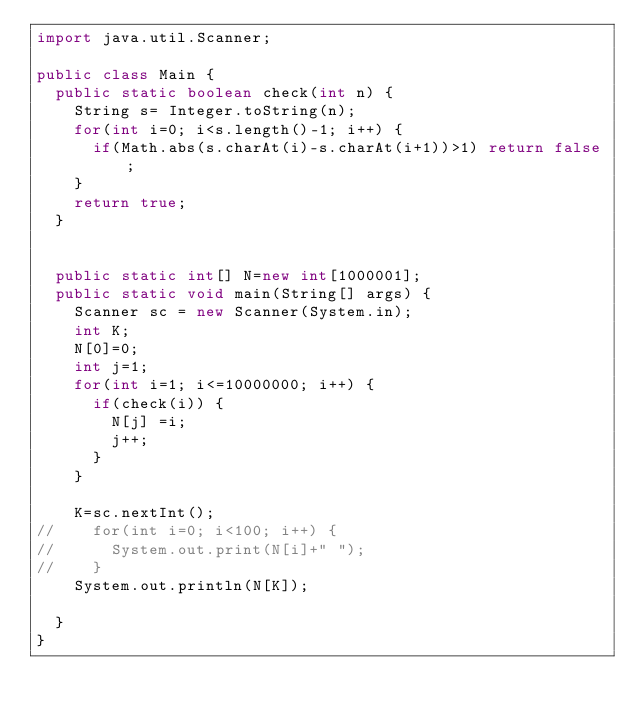<code> <loc_0><loc_0><loc_500><loc_500><_Java_>import java.util.Scanner;

public class Main {
	public static boolean check(int n) {
		String s= Integer.toString(n);
		for(int i=0; i<s.length()-1; i++) {
			if(Math.abs(s.charAt(i)-s.charAt(i+1))>1) return false;
		}
		return true;
	}
	
	
	public static int[] N=new int[1000001];
	public static void main(String[] args) {
		Scanner sc = new Scanner(System.in);
		int K;
		N[0]=0;
		int j=1;
		for(int i=1; i<=10000000; i++) {
			if(check(i)) {
				N[j] =i;
				j++;
			}
		}
		
		K=sc.nextInt();
//		for(int i=0; i<100; i++) {
//			System.out.print(N[i]+" ");
//		}
		System.out.println(N[K]);
		
	}
}</code> 